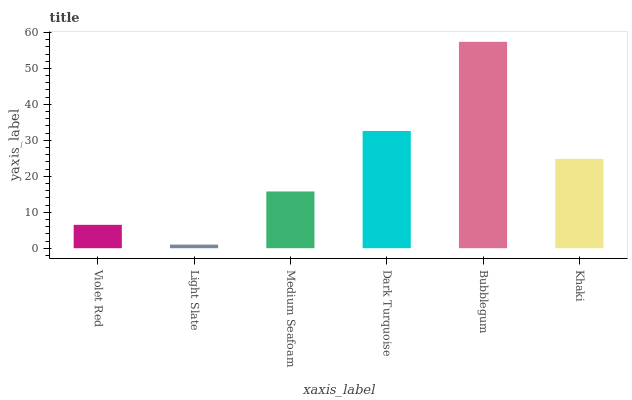Is Light Slate the minimum?
Answer yes or no. Yes. Is Bubblegum the maximum?
Answer yes or no. Yes. Is Medium Seafoam the minimum?
Answer yes or no. No. Is Medium Seafoam the maximum?
Answer yes or no. No. Is Medium Seafoam greater than Light Slate?
Answer yes or no. Yes. Is Light Slate less than Medium Seafoam?
Answer yes or no. Yes. Is Light Slate greater than Medium Seafoam?
Answer yes or no. No. Is Medium Seafoam less than Light Slate?
Answer yes or no. No. Is Khaki the high median?
Answer yes or no. Yes. Is Medium Seafoam the low median?
Answer yes or no. Yes. Is Medium Seafoam the high median?
Answer yes or no. No. Is Khaki the low median?
Answer yes or no. No. 